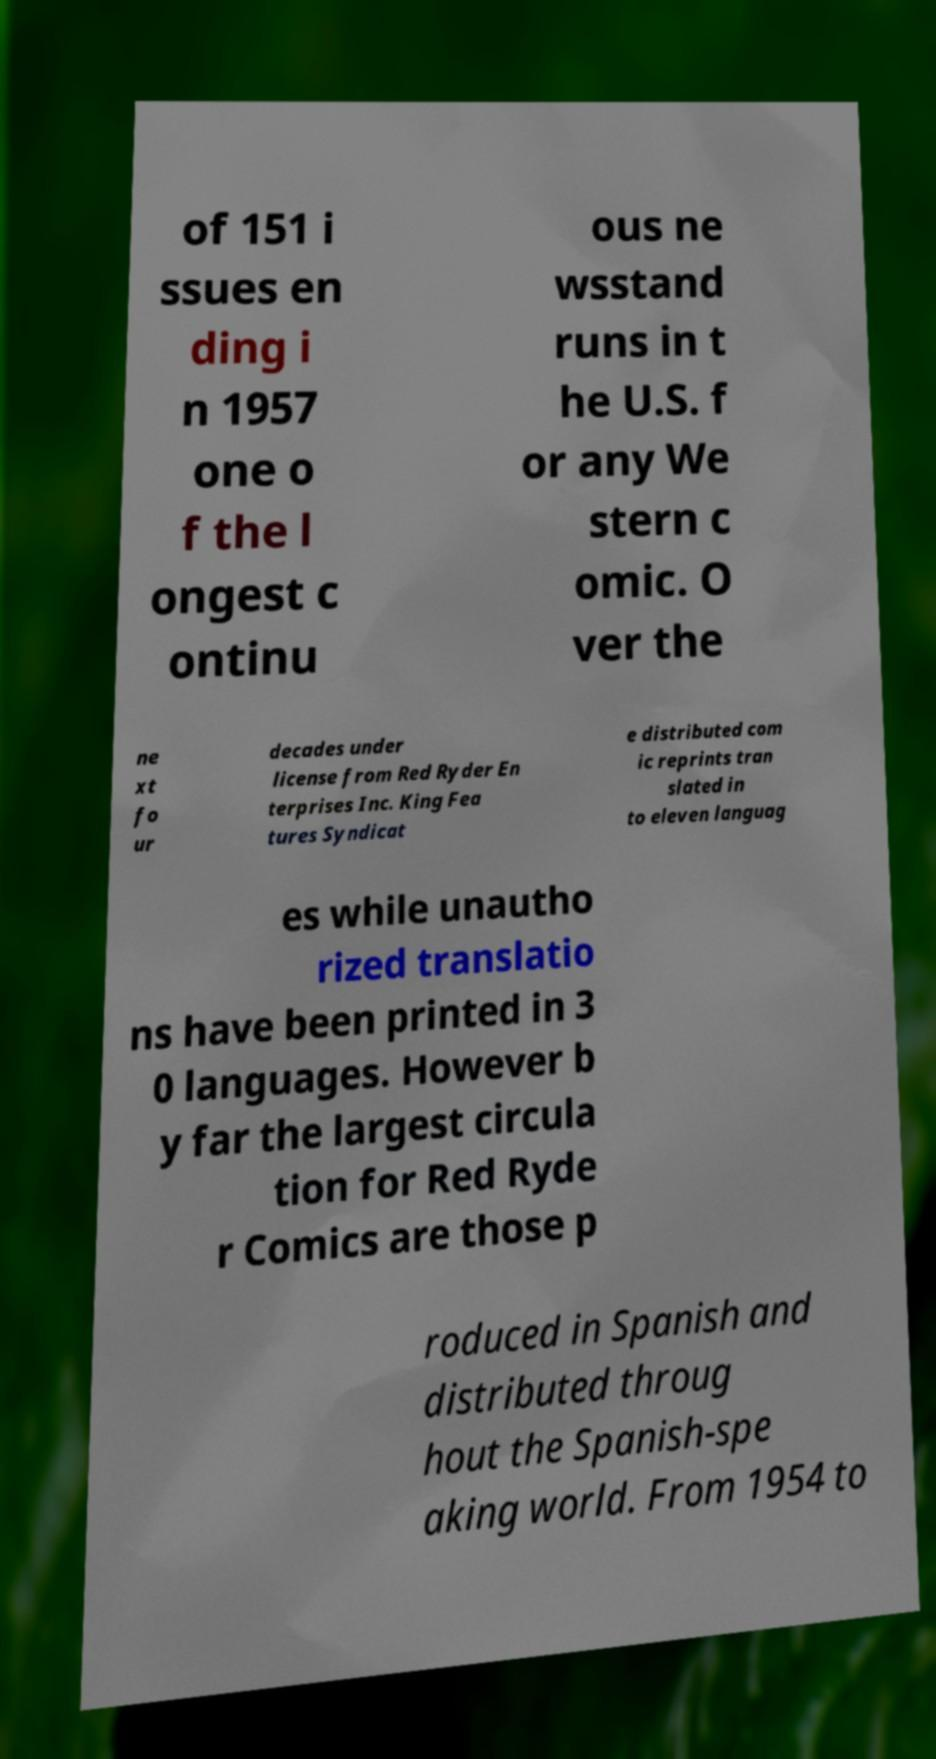Please read and relay the text visible in this image. What does it say? of 151 i ssues en ding i n 1957 one o f the l ongest c ontinu ous ne wsstand runs in t he U.S. f or any We stern c omic. O ver the ne xt fo ur decades under license from Red Ryder En terprises Inc. King Fea tures Syndicat e distributed com ic reprints tran slated in to eleven languag es while unautho rized translatio ns have been printed in 3 0 languages. However b y far the largest circula tion for Red Ryde r Comics are those p roduced in Spanish and distributed throug hout the Spanish-spe aking world. From 1954 to 